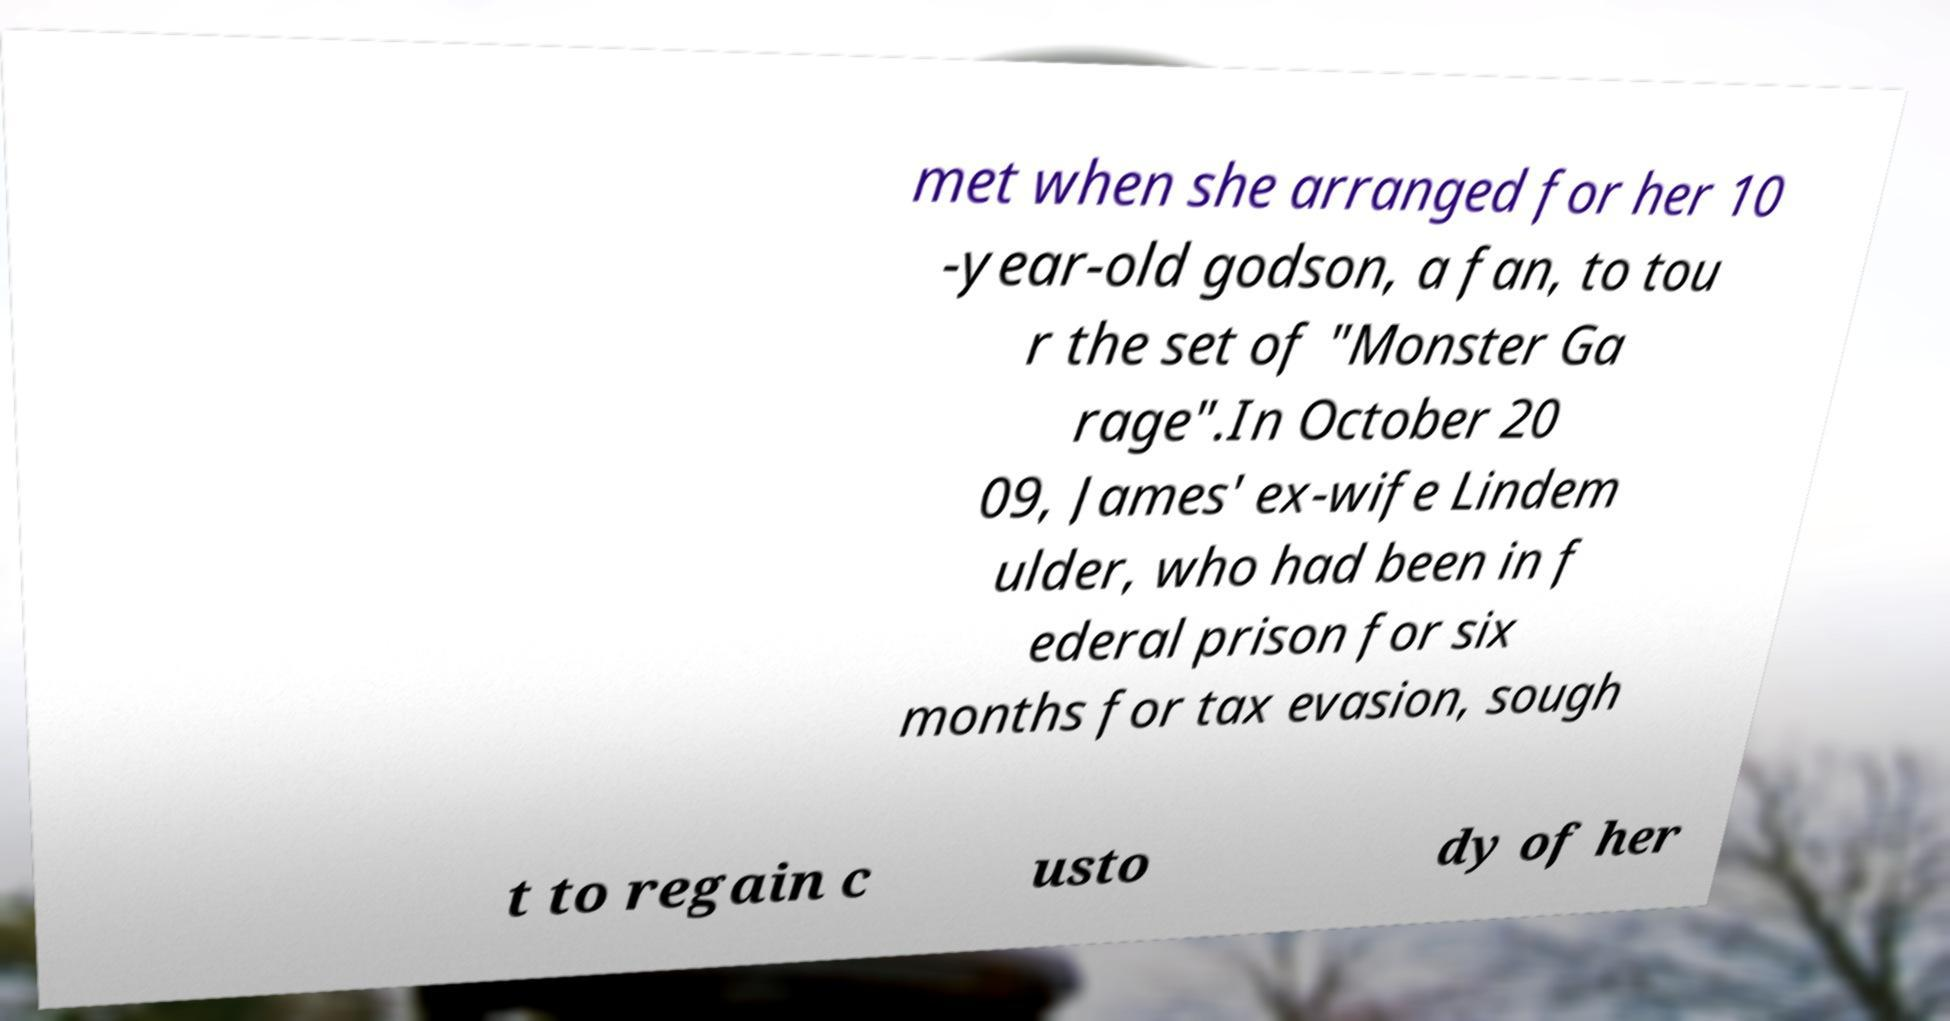Please read and relay the text visible in this image. What does it say? met when she arranged for her 10 -year-old godson, a fan, to tou r the set of "Monster Ga rage".In October 20 09, James' ex-wife Lindem ulder, who had been in f ederal prison for six months for tax evasion, sough t to regain c usto dy of her 